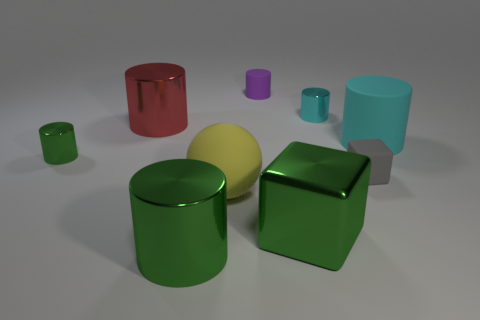What number of things are purple metallic spheres or big yellow balls?
Your answer should be very brief. 1. Is the cyan thing that is behind the red metallic cylinder made of the same material as the cyan cylinder that is right of the tiny gray matte object?
Provide a succinct answer. No. There is another small thing that is the same material as the small gray object; what color is it?
Keep it short and to the point. Purple. What number of other things have the same size as the gray thing?
Give a very brief answer. 3. What number of other things are there of the same color as the tiny rubber cube?
Offer a very short reply. 0. Is there anything else that has the same size as the gray object?
Offer a very short reply. Yes. There is a large shiny object that is behind the tiny green metallic thing; does it have the same shape as the large rubber thing that is behind the matte block?
Offer a terse response. Yes. There is a cyan thing that is the same size as the rubber block; what shape is it?
Offer a very short reply. Cylinder. Is the number of cubes that are to the left of the large red metallic object the same as the number of big yellow rubber objects on the right side of the sphere?
Offer a terse response. Yes. Are there any other things that are the same shape as the small gray object?
Your answer should be very brief. Yes. 